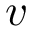<formula> <loc_0><loc_0><loc_500><loc_500>v</formula> 